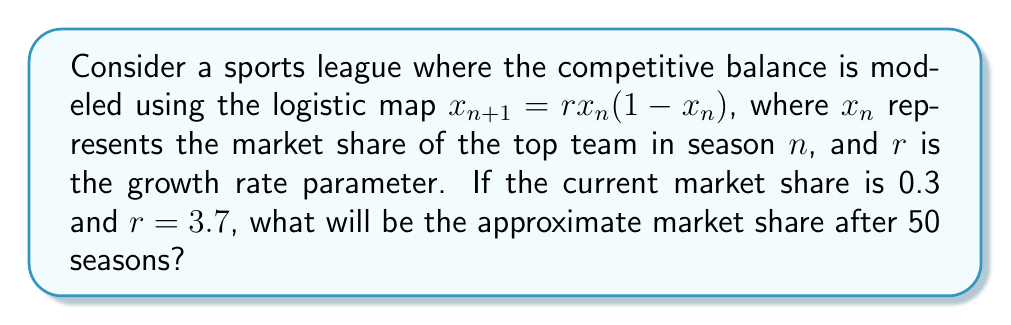Show me your answer to this math problem. To solve this problem, we'll use the logistic map equation iteratively:

1. Start with $x_0 = 0.3$ and $r = 3.7$

2. For each iteration, calculate:
   $x_{n+1} = 3.7x_n(1-x_n)$

3. Repeat this process 50 times to simulate 50 seasons:

   $x_1 = 3.7(0.3)(1-0.3) = 0.777$
   $x_2 = 3.7(0.777)(1-0.777) = 0.6407$
   $x_3 = 3.7(0.6407)(1-0.6407) = 0.8516$
   ...

4. Continue this process until $x_{50}$ is reached.

5. Due to the chaotic nature of the logistic map with $r = 3.7$, the final value will be highly sensitive to initial conditions and computational precision.

6. Using a computer to perform these iterations, we find that $x_{50}$ ≈ 0.3577

Note: The exact value may vary slightly depending on the precision of the calculations, which aligns with the unpredictable nature of chaotic systems and sports league dynamics.
Answer: 0.3577 